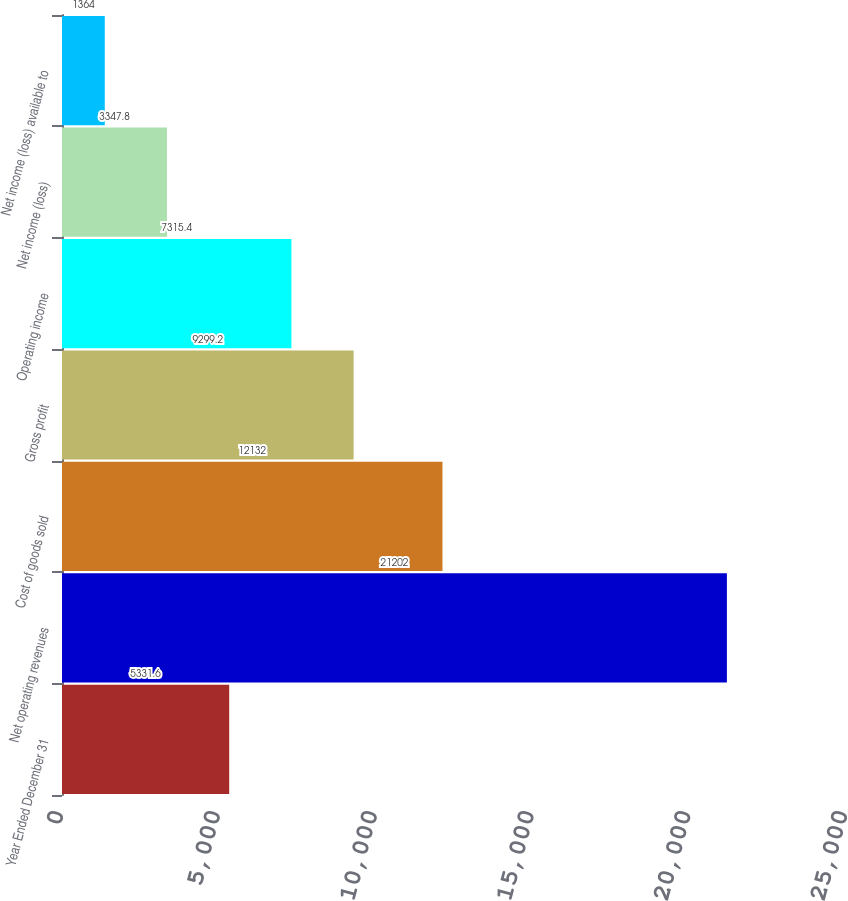<chart> <loc_0><loc_0><loc_500><loc_500><bar_chart><fcel>Year Ended December 31<fcel>Net operating revenues<fcel>Cost of goods sold<fcel>Gross profit<fcel>Operating income<fcel>Net income (loss)<fcel>Net income (loss) available to<nl><fcel>5331.6<fcel>21202<fcel>12132<fcel>9299.2<fcel>7315.4<fcel>3347.8<fcel>1364<nl></chart> 